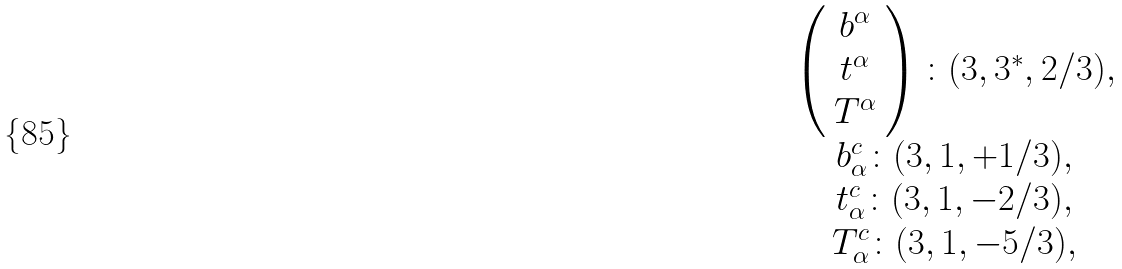Convert formula to latex. <formula><loc_0><loc_0><loc_500><loc_500>\begin{array} { c } { { \left ( \begin{array} { c } { { b ^ { \alpha } } } \\ { { t ^ { \alpha } } } \\ { { T ^ { \alpha } } } \end{array} \right ) \colon ( 3 , 3 ^ { * } , 2 / 3 ) , } } \\ { { \begin{array} { c } { { b _ { \alpha } ^ { c } \colon ( 3 , 1 , + 1 / 3 ) , } } \\ { { t _ { \alpha } ^ { c } \colon ( 3 , 1 , - 2 / 3 ) , } } \\ { { T _ { \alpha } ^ { c } \colon ( 3 , 1 , - 5 / 3 ) , } } \end{array} } } \end{array}</formula> 